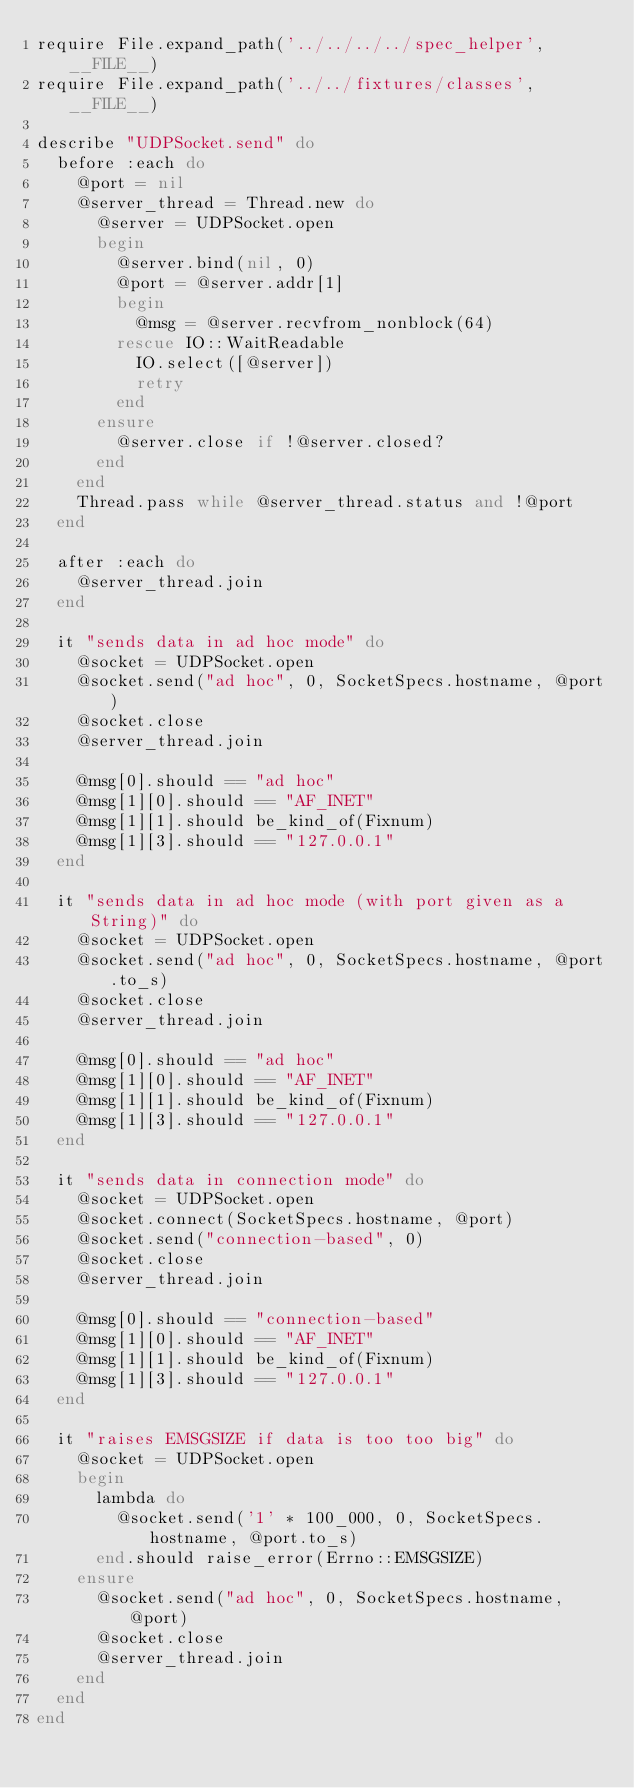Convert code to text. <code><loc_0><loc_0><loc_500><loc_500><_Ruby_>require File.expand_path('../../../../spec_helper', __FILE__)
require File.expand_path('../../fixtures/classes', __FILE__)

describe "UDPSocket.send" do
  before :each do
    @port = nil
    @server_thread = Thread.new do
      @server = UDPSocket.open
      begin
        @server.bind(nil, 0)
        @port = @server.addr[1]
        begin
          @msg = @server.recvfrom_nonblock(64)
        rescue IO::WaitReadable
          IO.select([@server])
          retry
        end
      ensure
        @server.close if !@server.closed?
      end
    end
    Thread.pass while @server_thread.status and !@port
  end

  after :each do
    @server_thread.join
  end

  it "sends data in ad hoc mode" do
    @socket = UDPSocket.open
    @socket.send("ad hoc", 0, SocketSpecs.hostname, @port)
    @socket.close
    @server_thread.join

    @msg[0].should == "ad hoc"
    @msg[1][0].should == "AF_INET"
    @msg[1][1].should be_kind_of(Fixnum)
    @msg[1][3].should == "127.0.0.1"
  end

  it "sends data in ad hoc mode (with port given as a String)" do
    @socket = UDPSocket.open
    @socket.send("ad hoc", 0, SocketSpecs.hostname, @port.to_s)
    @socket.close
    @server_thread.join

    @msg[0].should == "ad hoc"
    @msg[1][0].should == "AF_INET"
    @msg[1][1].should be_kind_of(Fixnum)
    @msg[1][3].should == "127.0.0.1"
  end

  it "sends data in connection mode" do
    @socket = UDPSocket.open
    @socket.connect(SocketSpecs.hostname, @port)
    @socket.send("connection-based", 0)
    @socket.close
    @server_thread.join

    @msg[0].should == "connection-based"
    @msg[1][0].should == "AF_INET"
    @msg[1][1].should be_kind_of(Fixnum)
    @msg[1][3].should == "127.0.0.1"
  end

  it "raises EMSGSIZE if data is too too big" do
    @socket = UDPSocket.open
    begin
      lambda do
        @socket.send('1' * 100_000, 0, SocketSpecs.hostname, @port.to_s)
      end.should raise_error(Errno::EMSGSIZE)
    ensure
      @socket.send("ad hoc", 0, SocketSpecs.hostname, @port)
      @socket.close
      @server_thread.join
    end
  end
end
</code> 